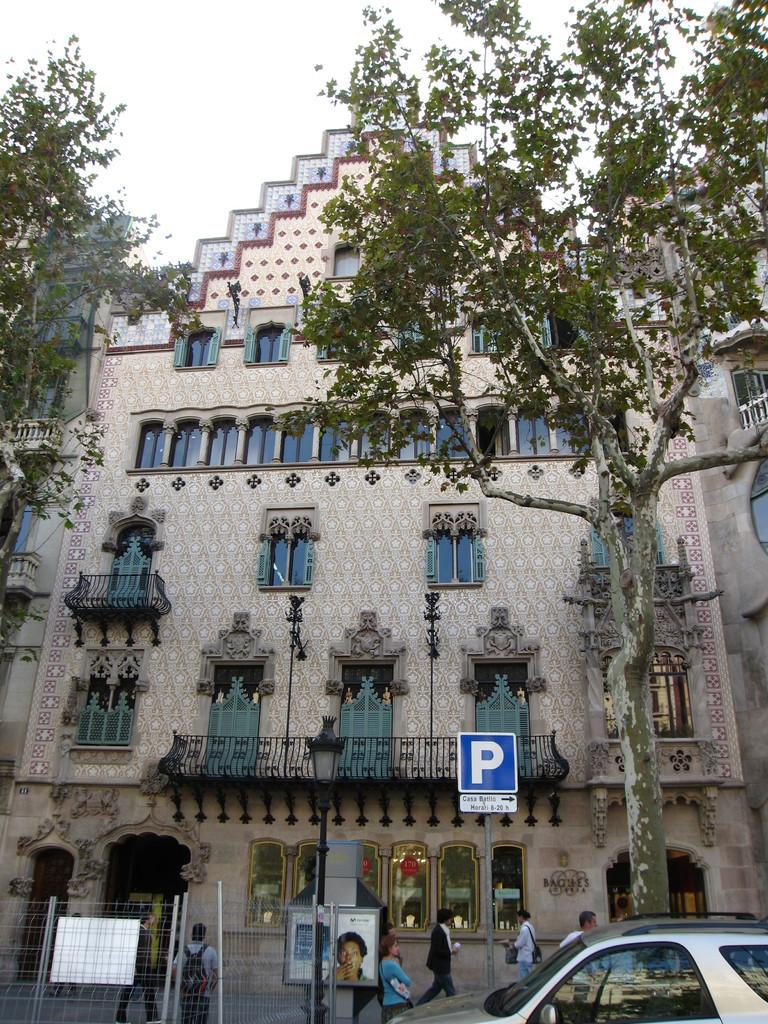What type of structures can be seen in the image? There are buildings in the image. What natural elements are present in the image? There are trees in the image. What architectural features can be observed in the image? Railings, lights, poles, boards, and a fence are visible in the image. Are there any vehicles in the image? Yes, there is a car in the image. Can you describe the people in the image? People are present in the image. What is visible at the top of the image? The sky is visible at the top of the image. What is the average income of the people in the image? There is no information about the income of the people in the image. Is there a playground visible in the image? There is no playground present in the image. 